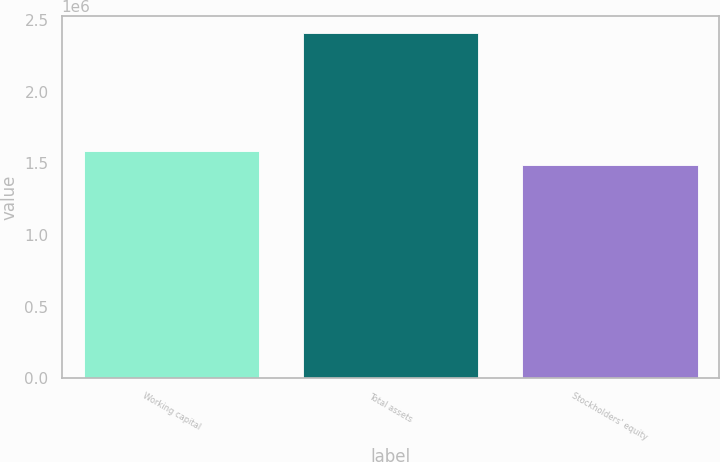<chart> <loc_0><loc_0><loc_500><loc_500><bar_chart><fcel>Working capital<fcel>Total assets<fcel>Stockholders' equity<nl><fcel>1.58714e+06<fcel>2.40571e+06<fcel>1.49031e+06<nl></chart> 